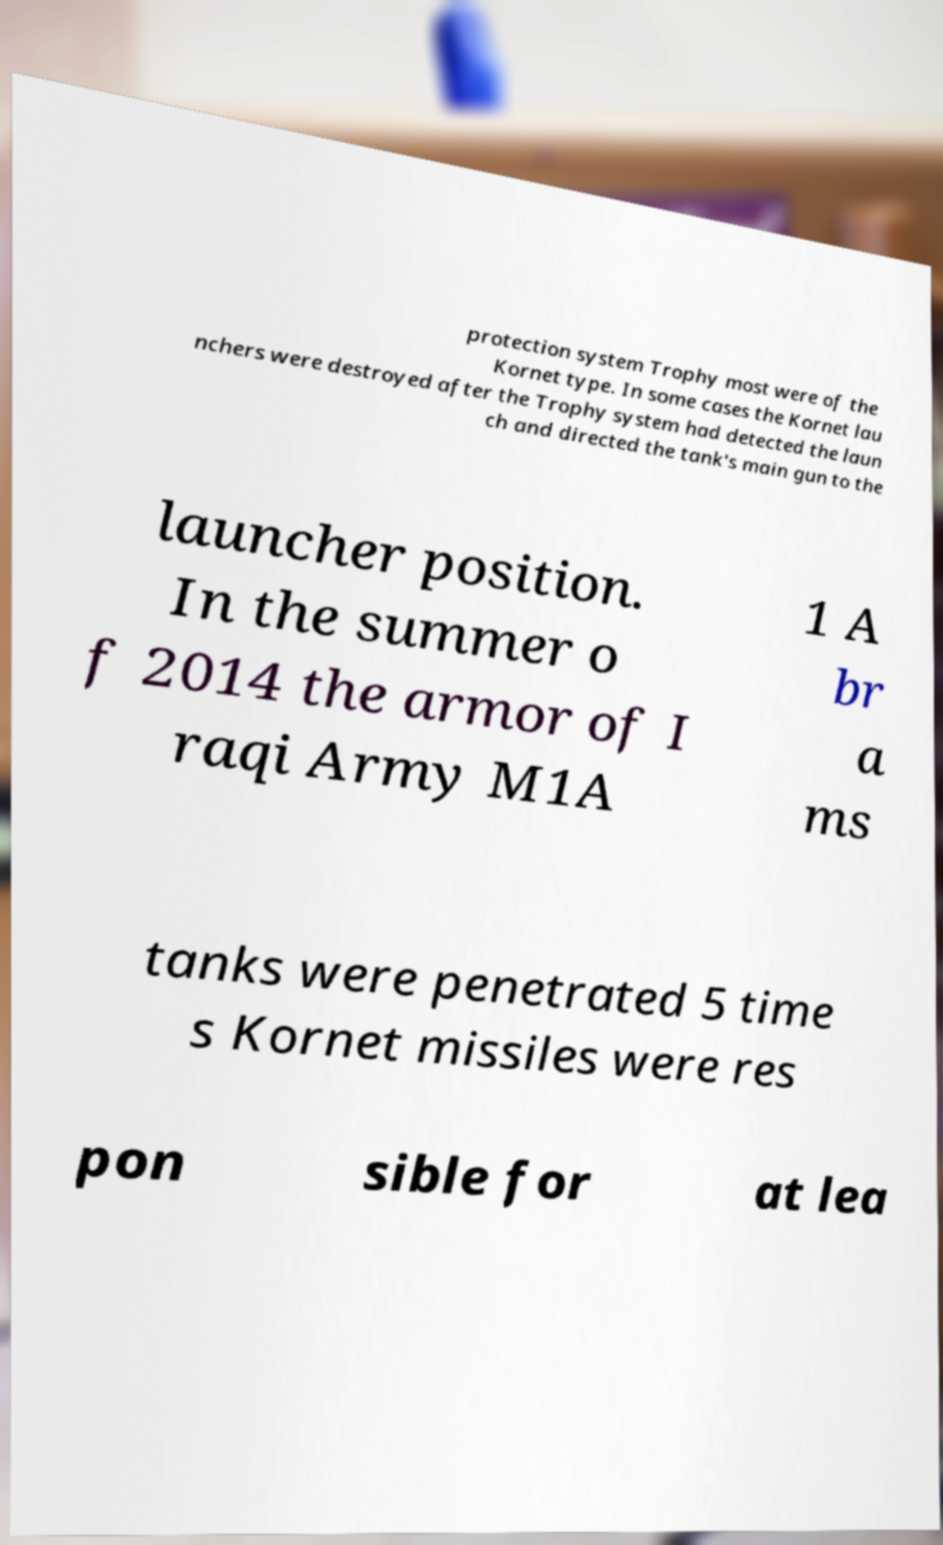Please read and relay the text visible in this image. What does it say? protection system Trophy most were of the Kornet type. In some cases the Kornet lau nchers were destroyed after the Trophy system had detected the laun ch and directed the tank's main gun to the launcher position. In the summer o f 2014 the armor of I raqi Army M1A 1 A br a ms tanks were penetrated 5 time s Kornet missiles were res pon sible for at lea 